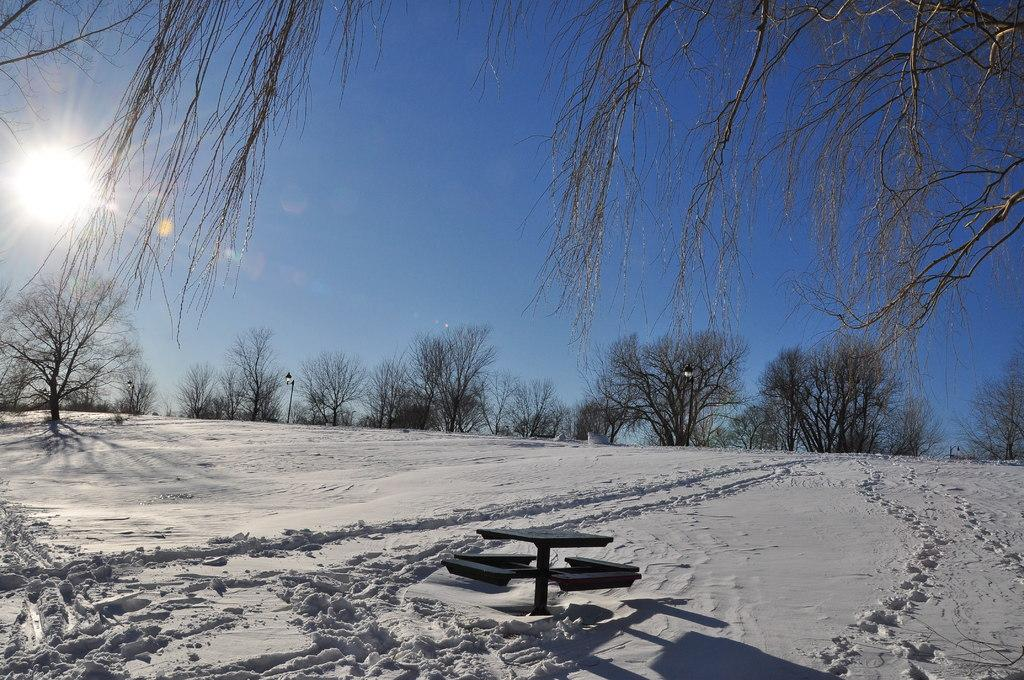What is the predominant color of the snow in the image? The snow in the image is white in color. What type of object can be seen in the image? There is a bench in the image. What can be seen in the background of the image? The background of the image includes dried trees. What is the color of the sky in the image? The sky is blue in color. Can you see a vase on the bench in the image? There is no vase present on the bench in the image. Is there a bun on the snow in the image? There is no bun present on the snow in the image. 